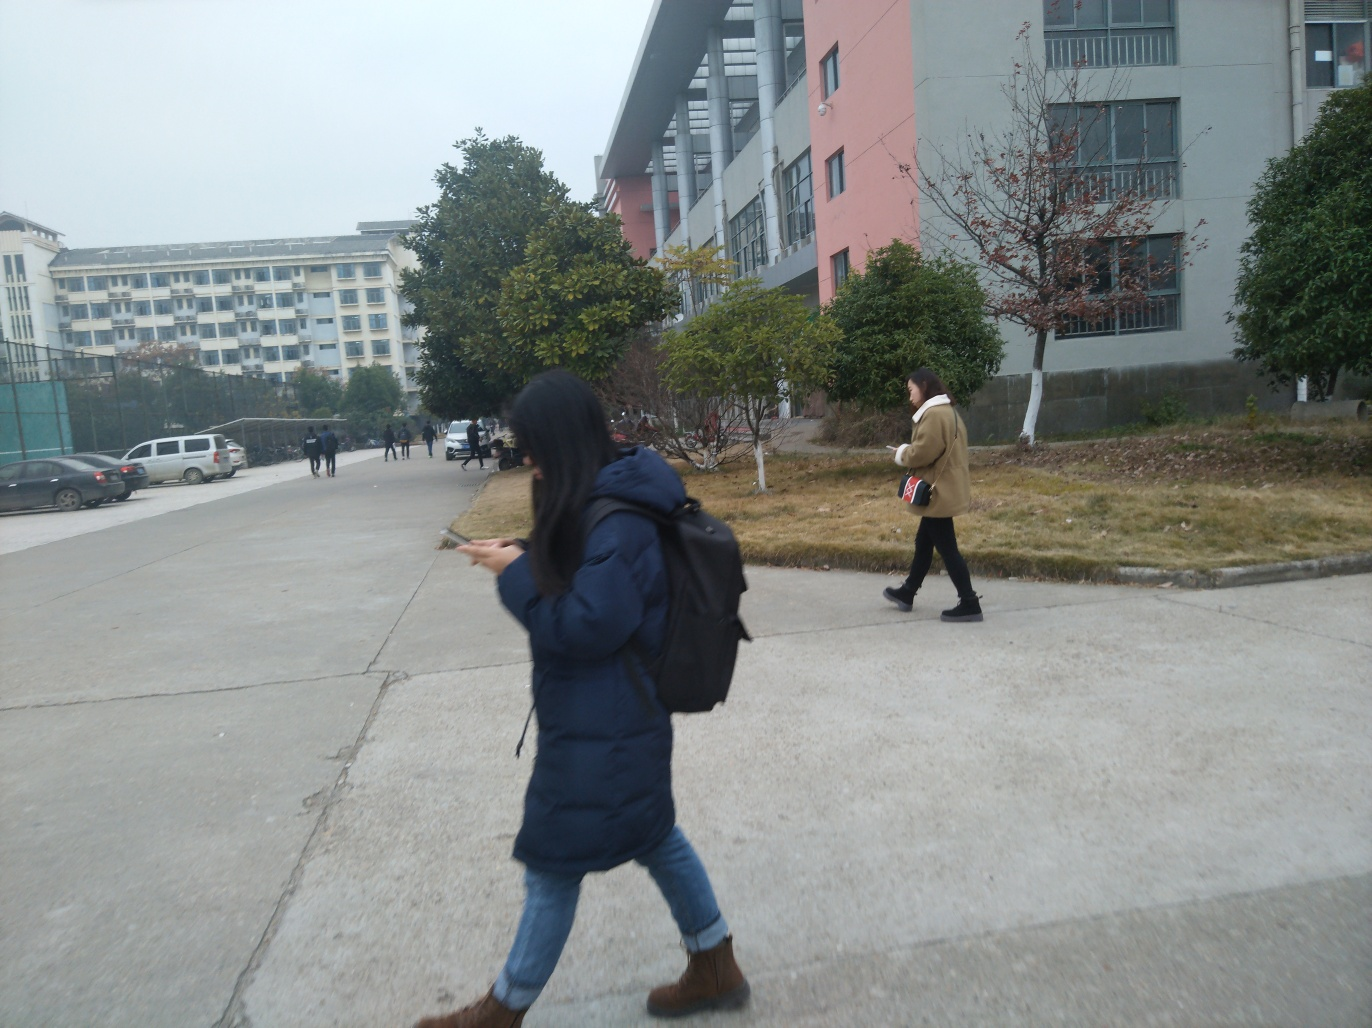Are the main subjects in the image clear? Yes, the image prominently features two individuals walking in opposite directions along a street, with one of them focused on her phone and the other carrying a book. The clarity of the main subjects allows for observation of their actions and attire in the context of the urban environment. 